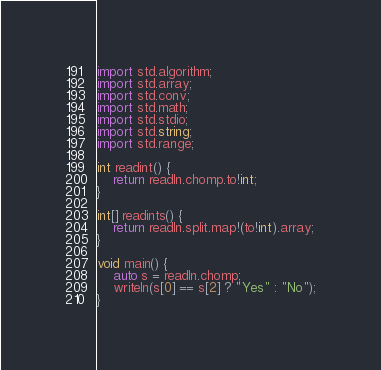Convert code to text. <code><loc_0><loc_0><loc_500><loc_500><_D_>import std.algorithm;
import std.array;
import std.conv;
import std.math;
import std.stdio;
import std.string;
import std.range;

int readint() {
    return readln.chomp.to!int;
}

int[] readints() {
    return readln.split.map!(to!int).array;
}

void main() {
    auto s = readln.chomp;
    writeln(s[0] == s[2] ? "Yes" : "No");
}
</code> 